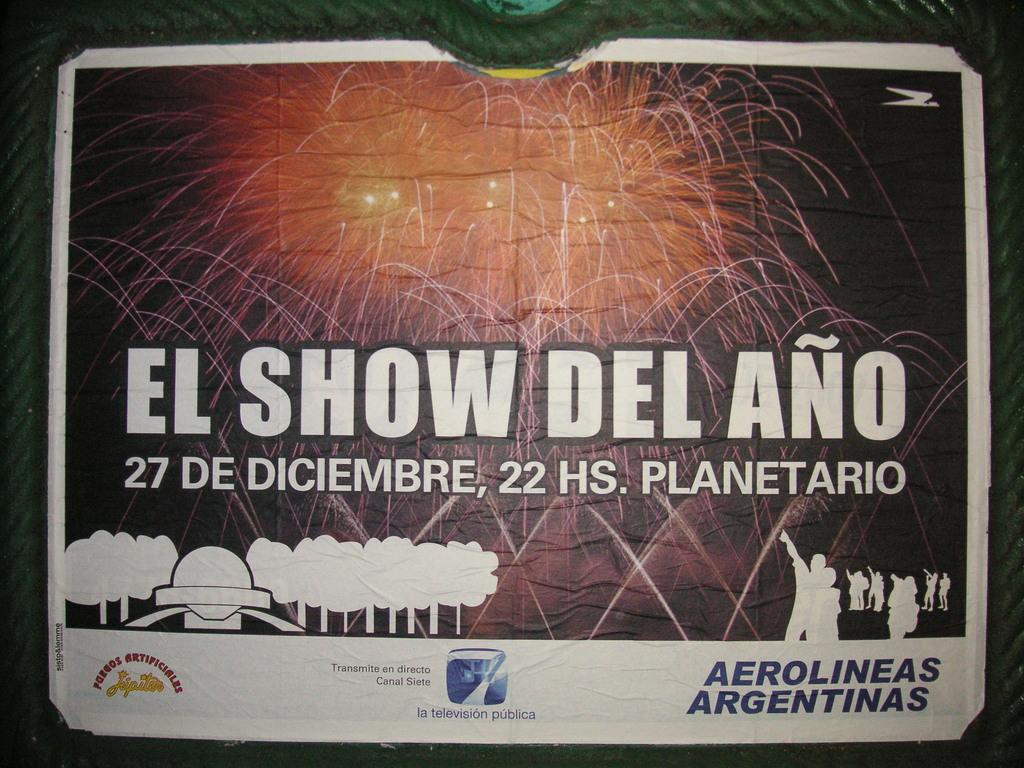<image>
Summarize the visual content of the image. El show del ano takes place in diciembre which is spanish 